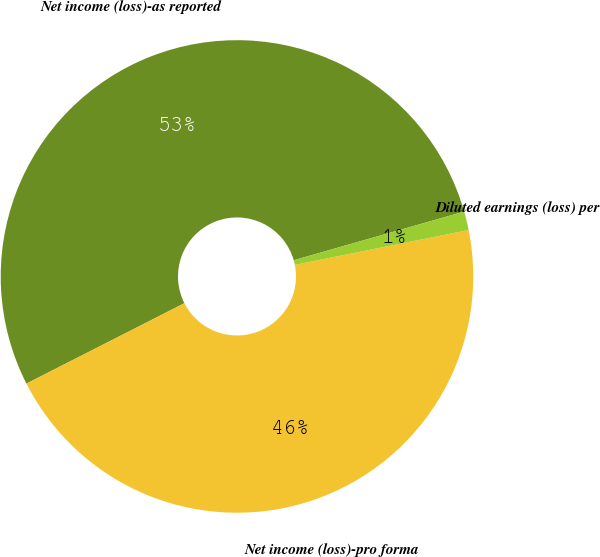Convert chart. <chart><loc_0><loc_0><loc_500><loc_500><pie_chart><fcel>Net income (loss)-as reported<fcel>Net income (loss)-pro forma<fcel>Diluted earnings (loss) per<nl><fcel>53.06%<fcel>45.65%<fcel>1.28%<nl></chart> 